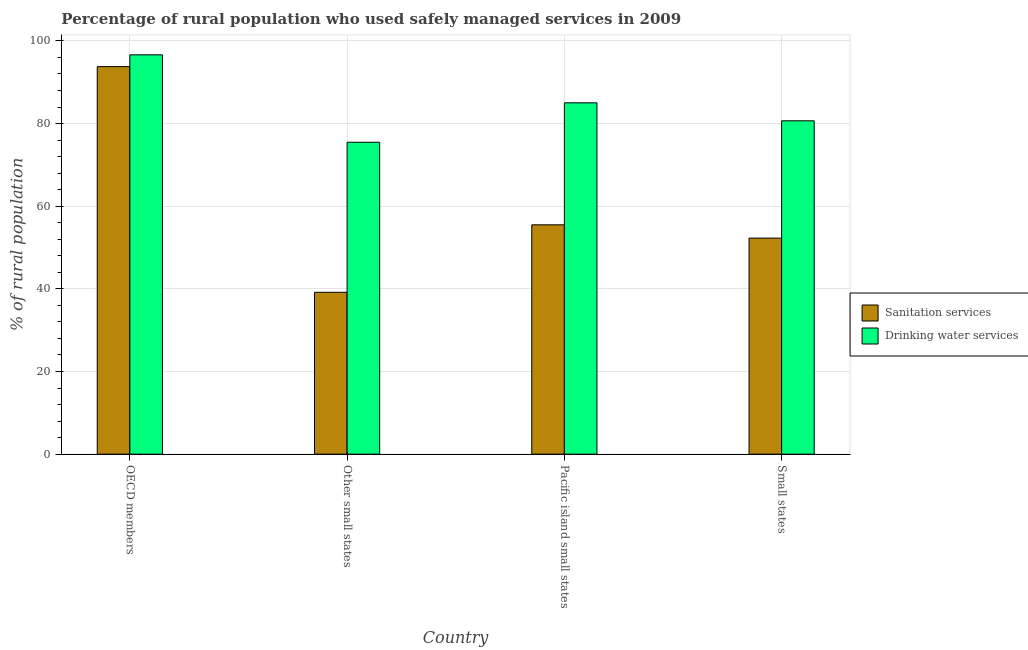How many different coloured bars are there?
Your answer should be compact. 2. How many groups of bars are there?
Your answer should be compact. 4. Are the number of bars per tick equal to the number of legend labels?
Your response must be concise. Yes. Are the number of bars on each tick of the X-axis equal?
Your response must be concise. Yes. How many bars are there on the 2nd tick from the right?
Provide a short and direct response. 2. What is the label of the 4th group of bars from the left?
Provide a short and direct response. Small states. In how many cases, is the number of bars for a given country not equal to the number of legend labels?
Keep it short and to the point. 0. What is the percentage of rural population who used drinking water services in Pacific island small states?
Provide a succinct answer. 85.02. Across all countries, what is the maximum percentage of rural population who used drinking water services?
Give a very brief answer. 96.63. Across all countries, what is the minimum percentage of rural population who used drinking water services?
Your answer should be compact. 75.47. In which country was the percentage of rural population who used drinking water services maximum?
Your response must be concise. OECD members. In which country was the percentage of rural population who used sanitation services minimum?
Your response must be concise. Other small states. What is the total percentage of rural population who used sanitation services in the graph?
Keep it short and to the point. 240.72. What is the difference between the percentage of rural population who used drinking water services in Other small states and that in Small states?
Provide a short and direct response. -5.19. What is the difference between the percentage of rural population who used drinking water services in OECD members and the percentage of rural population who used sanitation services in Other small states?
Give a very brief answer. 57.46. What is the average percentage of rural population who used drinking water services per country?
Keep it short and to the point. 84.45. What is the difference between the percentage of rural population who used drinking water services and percentage of rural population who used sanitation services in OECD members?
Provide a succinct answer. 2.85. In how many countries, is the percentage of rural population who used drinking water services greater than 80 %?
Ensure brevity in your answer.  3. What is the ratio of the percentage of rural population who used sanitation services in OECD members to that in Pacific island small states?
Your answer should be very brief. 1.69. What is the difference between the highest and the second highest percentage of rural population who used sanitation services?
Make the answer very short. 38.28. What is the difference between the highest and the lowest percentage of rural population who used sanitation services?
Offer a terse response. 54.61. In how many countries, is the percentage of rural population who used drinking water services greater than the average percentage of rural population who used drinking water services taken over all countries?
Offer a very short reply. 2. Is the sum of the percentage of rural population who used drinking water services in Pacific island small states and Small states greater than the maximum percentage of rural population who used sanitation services across all countries?
Offer a very short reply. Yes. What does the 2nd bar from the left in Small states represents?
Provide a short and direct response. Drinking water services. What does the 1st bar from the right in Small states represents?
Your answer should be very brief. Drinking water services. How many bars are there?
Your response must be concise. 8. What is the difference between two consecutive major ticks on the Y-axis?
Provide a succinct answer. 20. Does the graph contain any zero values?
Offer a terse response. No. How are the legend labels stacked?
Your answer should be very brief. Vertical. What is the title of the graph?
Your answer should be compact. Percentage of rural population who used safely managed services in 2009. What is the label or title of the X-axis?
Make the answer very short. Country. What is the label or title of the Y-axis?
Offer a very short reply. % of rural population. What is the % of rural population in Sanitation services in OECD members?
Offer a very short reply. 93.77. What is the % of rural population in Drinking water services in OECD members?
Your answer should be very brief. 96.63. What is the % of rural population in Sanitation services in Other small states?
Ensure brevity in your answer.  39.17. What is the % of rural population of Drinking water services in Other small states?
Keep it short and to the point. 75.47. What is the % of rural population in Sanitation services in Pacific island small states?
Provide a short and direct response. 55.5. What is the % of rural population in Drinking water services in Pacific island small states?
Ensure brevity in your answer.  85.02. What is the % of rural population in Sanitation services in Small states?
Provide a succinct answer. 52.28. What is the % of rural population in Drinking water services in Small states?
Make the answer very short. 80.67. Across all countries, what is the maximum % of rural population in Sanitation services?
Your response must be concise. 93.77. Across all countries, what is the maximum % of rural population of Drinking water services?
Provide a short and direct response. 96.63. Across all countries, what is the minimum % of rural population in Sanitation services?
Offer a terse response. 39.17. Across all countries, what is the minimum % of rural population in Drinking water services?
Your answer should be very brief. 75.47. What is the total % of rural population of Sanitation services in the graph?
Your response must be concise. 240.72. What is the total % of rural population of Drinking water services in the graph?
Provide a succinct answer. 337.79. What is the difference between the % of rural population in Sanitation services in OECD members and that in Other small states?
Make the answer very short. 54.61. What is the difference between the % of rural population in Drinking water services in OECD members and that in Other small states?
Offer a terse response. 21.16. What is the difference between the % of rural population in Sanitation services in OECD members and that in Pacific island small states?
Your response must be concise. 38.28. What is the difference between the % of rural population in Drinking water services in OECD members and that in Pacific island small states?
Offer a terse response. 11.61. What is the difference between the % of rural population in Sanitation services in OECD members and that in Small states?
Offer a terse response. 41.49. What is the difference between the % of rural population of Drinking water services in OECD members and that in Small states?
Provide a succinct answer. 15.96. What is the difference between the % of rural population of Sanitation services in Other small states and that in Pacific island small states?
Make the answer very short. -16.33. What is the difference between the % of rural population in Drinking water services in Other small states and that in Pacific island small states?
Offer a terse response. -9.55. What is the difference between the % of rural population of Sanitation services in Other small states and that in Small states?
Make the answer very short. -13.11. What is the difference between the % of rural population of Drinking water services in Other small states and that in Small states?
Make the answer very short. -5.19. What is the difference between the % of rural population of Sanitation services in Pacific island small states and that in Small states?
Give a very brief answer. 3.22. What is the difference between the % of rural population in Drinking water services in Pacific island small states and that in Small states?
Your answer should be compact. 4.35. What is the difference between the % of rural population in Sanitation services in OECD members and the % of rural population in Drinking water services in Other small states?
Make the answer very short. 18.3. What is the difference between the % of rural population of Sanitation services in OECD members and the % of rural population of Drinking water services in Pacific island small states?
Provide a succinct answer. 8.76. What is the difference between the % of rural population of Sanitation services in OECD members and the % of rural population of Drinking water services in Small states?
Provide a succinct answer. 13.11. What is the difference between the % of rural population of Sanitation services in Other small states and the % of rural population of Drinking water services in Pacific island small states?
Offer a very short reply. -45.85. What is the difference between the % of rural population of Sanitation services in Other small states and the % of rural population of Drinking water services in Small states?
Your answer should be very brief. -41.5. What is the difference between the % of rural population of Sanitation services in Pacific island small states and the % of rural population of Drinking water services in Small states?
Your answer should be very brief. -25.17. What is the average % of rural population of Sanitation services per country?
Make the answer very short. 60.18. What is the average % of rural population of Drinking water services per country?
Ensure brevity in your answer.  84.45. What is the difference between the % of rural population in Sanitation services and % of rural population in Drinking water services in OECD members?
Provide a short and direct response. -2.85. What is the difference between the % of rural population of Sanitation services and % of rural population of Drinking water services in Other small states?
Ensure brevity in your answer.  -36.31. What is the difference between the % of rural population of Sanitation services and % of rural population of Drinking water services in Pacific island small states?
Your answer should be very brief. -29.52. What is the difference between the % of rural population in Sanitation services and % of rural population in Drinking water services in Small states?
Your response must be concise. -28.39. What is the ratio of the % of rural population in Sanitation services in OECD members to that in Other small states?
Provide a succinct answer. 2.39. What is the ratio of the % of rural population in Drinking water services in OECD members to that in Other small states?
Provide a succinct answer. 1.28. What is the ratio of the % of rural population in Sanitation services in OECD members to that in Pacific island small states?
Keep it short and to the point. 1.69. What is the ratio of the % of rural population of Drinking water services in OECD members to that in Pacific island small states?
Your response must be concise. 1.14. What is the ratio of the % of rural population of Sanitation services in OECD members to that in Small states?
Give a very brief answer. 1.79. What is the ratio of the % of rural population in Drinking water services in OECD members to that in Small states?
Offer a terse response. 1.2. What is the ratio of the % of rural population of Sanitation services in Other small states to that in Pacific island small states?
Provide a short and direct response. 0.71. What is the ratio of the % of rural population in Drinking water services in Other small states to that in Pacific island small states?
Give a very brief answer. 0.89. What is the ratio of the % of rural population of Sanitation services in Other small states to that in Small states?
Your answer should be very brief. 0.75. What is the ratio of the % of rural population in Drinking water services in Other small states to that in Small states?
Provide a succinct answer. 0.94. What is the ratio of the % of rural population in Sanitation services in Pacific island small states to that in Small states?
Keep it short and to the point. 1.06. What is the ratio of the % of rural population in Drinking water services in Pacific island small states to that in Small states?
Provide a succinct answer. 1.05. What is the difference between the highest and the second highest % of rural population in Sanitation services?
Ensure brevity in your answer.  38.28. What is the difference between the highest and the second highest % of rural population of Drinking water services?
Your response must be concise. 11.61. What is the difference between the highest and the lowest % of rural population in Sanitation services?
Offer a very short reply. 54.61. What is the difference between the highest and the lowest % of rural population of Drinking water services?
Provide a succinct answer. 21.16. 